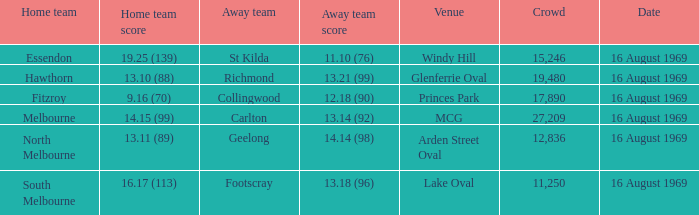Who was home at Princes Park? 9.16 (70). 